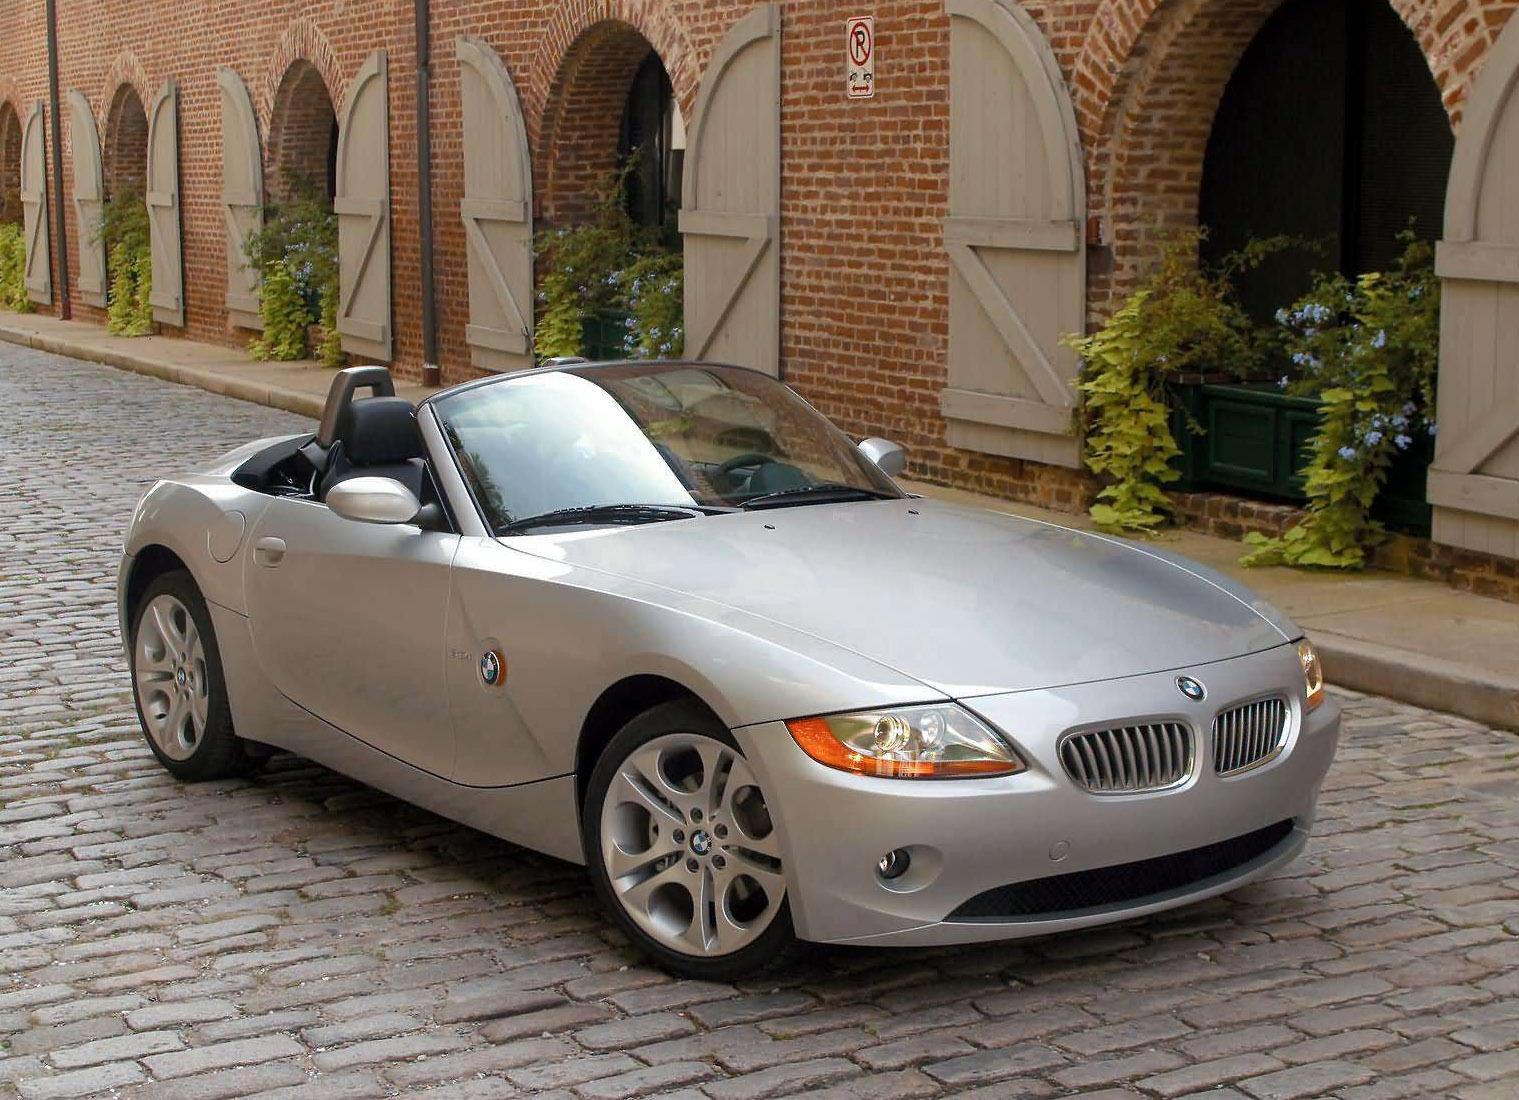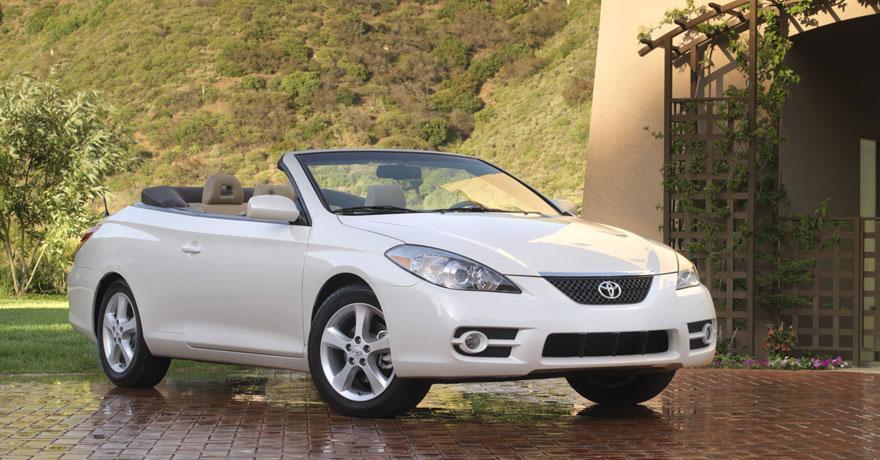The first image is the image on the left, the second image is the image on the right. For the images displayed, is the sentence "A body of water is in the background of a convertible in one of the images." factually correct? Answer yes or no. No. The first image is the image on the left, the second image is the image on the right. Assess this claim about the two images: "One of the cars is red.". Correct or not? Answer yes or no. No. 